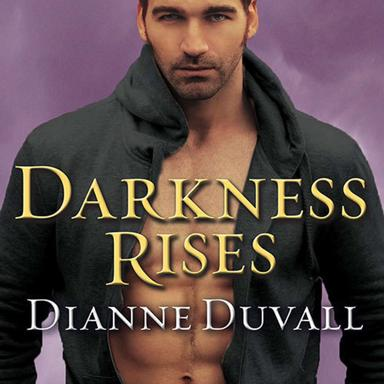How does the cover design of 'Darkness Rises' contribute to its paranormal theme? The cover of 'Darkness Rises' features a brooding male figure with intense eyes, set against a dark, mystical backdrop. This design enhances the novel's paranormal theme by invoking a sense of mystery and allure, typical of supernatural narratives. 